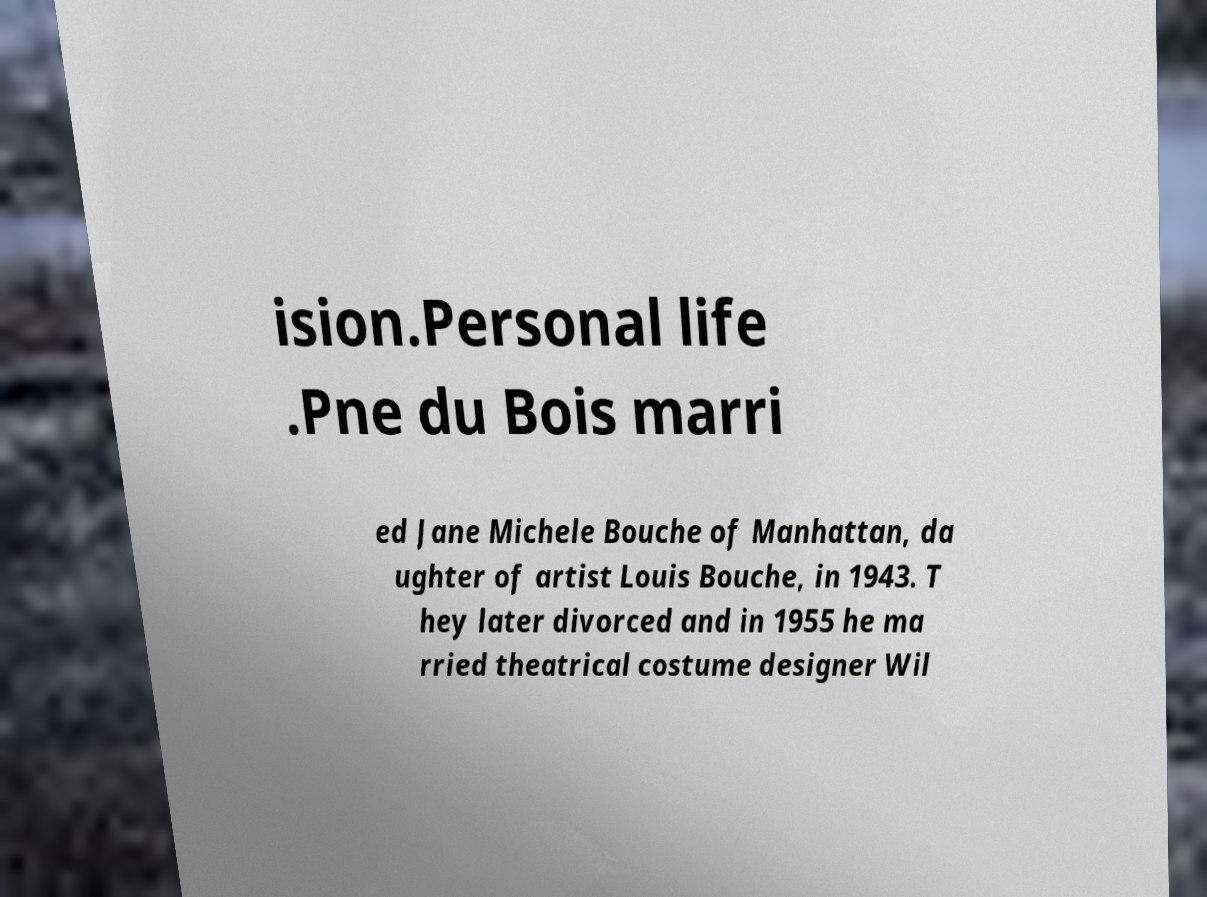Please identify and transcribe the text found in this image. ision.Personal life .Pne du Bois marri ed Jane Michele Bouche of Manhattan, da ughter of artist Louis Bouche, in 1943. T hey later divorced and in 1955 he ma rried theatrical costume designer Wil 